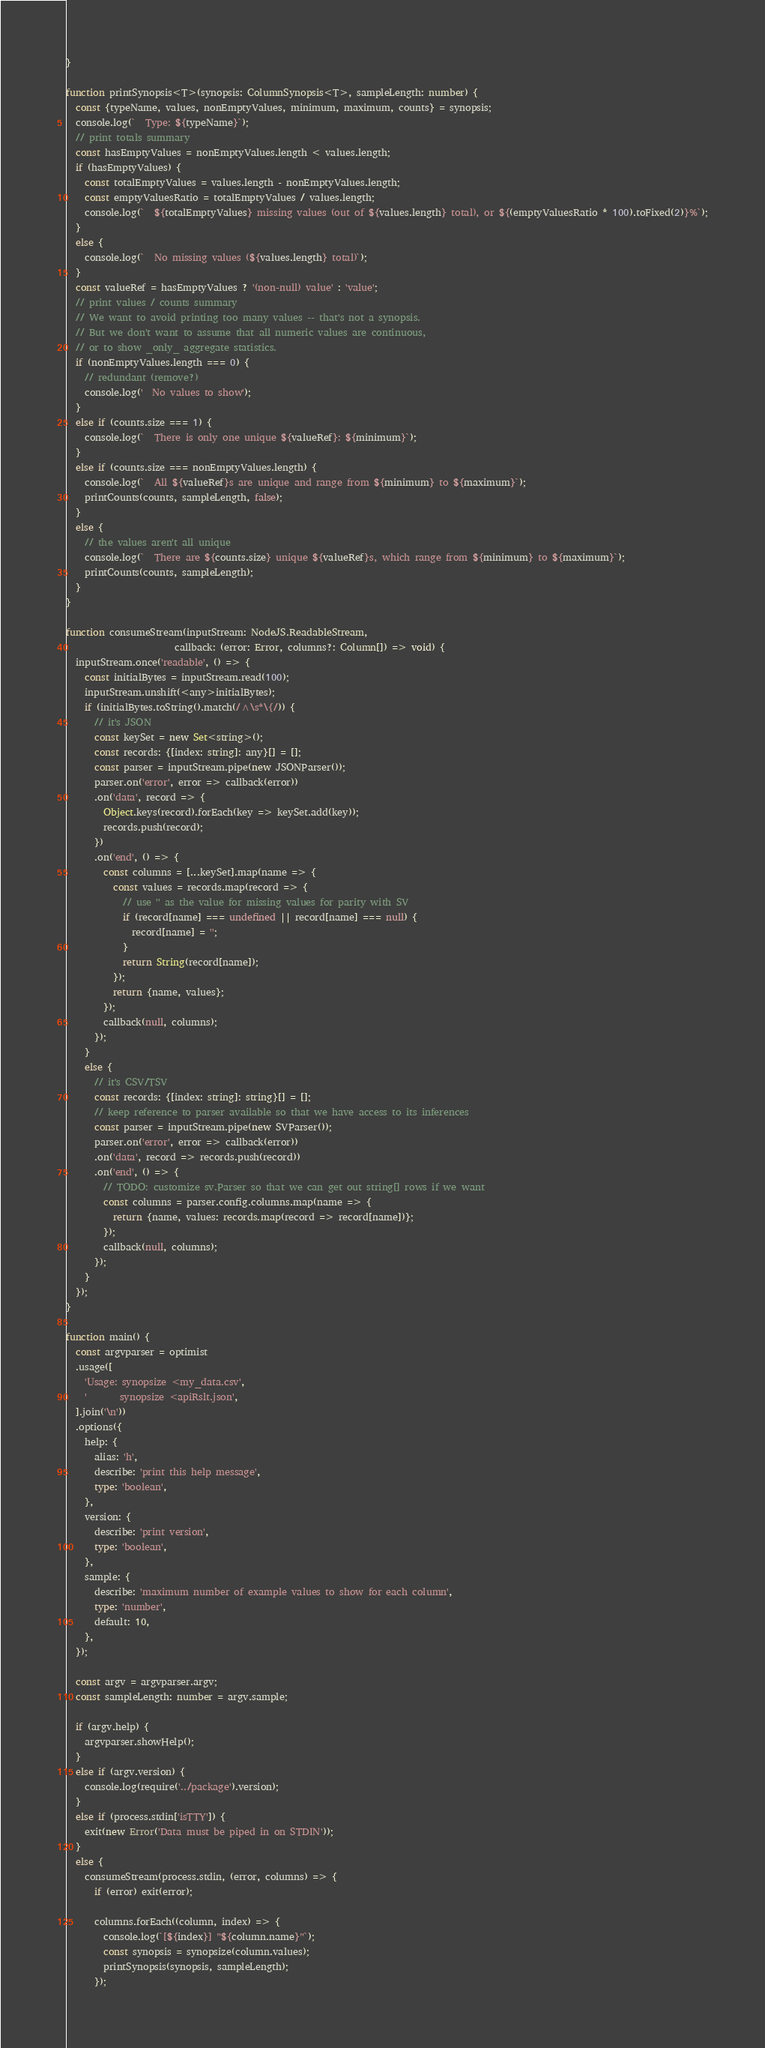Convert code to text. <code><loc_0><loc_0><loc_500><loc_500><_TypeScript_>}

function printSynopsis<T>(synopsis: ColumnSynopsis<T>, sampleLength: number) {
  const {typeName, values, nonEmptyValues, minimum, maximum, counts} = synopsis;
  console.log(`  Type: ${typeName}`);
  // print totals summary
  const hasEmptyValues = nonEmptyValues.length < values.length;
  if (hasEmptyValues) {
    const totalEmptyValues = values.length - nonEmptyValues.length;
    const emptyValuesRatio = totalEmptyValues / values.length;
    console.log(`  ${totalEmptyValues} missing values (out of ${values.length} total), or ${(emptyValuesRatio * 100).toFixed(2)}%`);
  }
  else {
    console.log(`  No missing values (${values.length} total)`);
  }
  const valueRef = hasEmptyValues ? '(non-null) value' : 'value';
  // print values / counts summary
  // We want to avoid printing too many values -- that's not a synopsis.
  // But we don't want to assume that all numeric values are continuous,
  // or to show _only_ aggregate statistics.
  if (nonEmptyValues.length === 0) {
    // redundant (remove?)
    console.log('  No values to show');
  }
  else if (counts.size === 1) {
    console.log(`  There is only one unique ${valueRef}: ${minimum}`);
  }
  else if (counts.size === nonEmptyValues.length) {
    console.log(`  All ${valueRef}s are unique and range from ${minimum} to ${maximum}`);
    printCounts(counts, sampleLength, false);
  }
  else {
    // the values aren't all unique
    console.log(`  There are ${counts.size} unique ${valueRef}s, which range from ${minimum} to ${maximum}`);
    printCounts(counts, sampleLength);
  }
}

function consumeStream(inputStream: NodeJS.ReadableStream,
                       callback: (error: Error, columns?: Column[]) => void) {
  inputStream.once('readable', () => {
    const initialBytes = inputStream.read(100);
    inputStream.unshift(<any>initialBytes);
    if (initialBytes.toString().match(/^\s*\{/)) {
      // it's JSON
      const keySet = new Set<string>();
      const records: {[index: string]: any}[] = [];
      const parser = inputStream.pipe(new JSONParser());
      parser.on('error', error => callback(error))
      .on('data', record => {
        Object.keys(record).forEach(key => keySet.add(key));
        records.push(record);
      })
      .on('end', () => {
        const columns = [...keySet].map(name => {
          const values = records.map(record => {
            // use '' as the value for missing values for parity with SV
            if (record[name] === undefined || record[name] === null) {
              record[name] = '';
            }
            return String(record[name]);
          });
          return {name, values};
        });
        callback(null, columns);
      });
    }
    else {
      // it's CSV/TSV
      const records: {[index: string]: string}[] = [];
      // keep reference to parser available so that we have access to its inferences
      const parser = inputStream.pipe(new SVParser());
      parser.on('error', error => callback(error))
      .on('data', record => records.push(record))
      .on('end', () => {
        // TODO: customize sv.Parser so that we can get out string[] rows if we want
        const columns = parser.config.columns.map(name => {
          return {name, values: records.map(record => record[name])};
        });
        callback(null, columns);
      });
    }
  });
}

function main() {
  const argvparser = optimist
  .usage([
    'Usage: synopsize <my_data.csv',
    '       synopsize <apiRslt.json',
  ].join('\n'))
  .options({
    help: {
      alias: 'h',
      describe: 'print this help message',
      type: 'boolean',
    },
    version: {
      describe: 'print version',
      type: 'boolean',
    },
    sample: {
      describe: 'maximum number of example values to show for each column',
      type: 'number',
      default: 10,
    },
  });

  const argv = argvparser.argv;
  const sampleLength: number = argv.sample;

  if (argv.help) {
    argvparser.showHelp();
  }
  else if (argv.version) {
    console.log(require('../package').version);
  }
  else if (process.stdin['isTTY']) {
    exit(new Error('Data must be piped in on STDIN'));
  }
  else {
    consumeStream(process.stdin, (error, columns) => {
      if (error) exit(error);

      columns.forEach((column, index) => {
        console.log(`[${index}] "${column.name}"`);
        const synopsis = synopsize(column.values);
        printSynopsis(synopsis, sampleLength);
      });</code> 